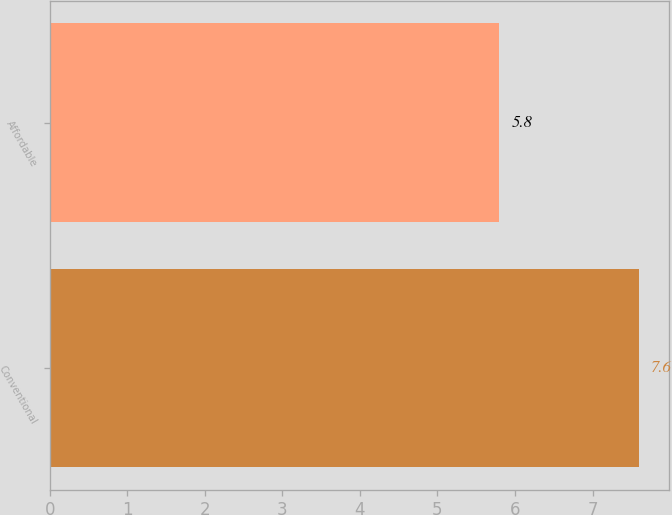Convert chart. <chart><loc_0><loc_0><loc_500><loc_500><bar_chart><fcel>Conventional<fcel>Affordable<nl><fcel>7.6<fcel>5.8<nl></chart> 